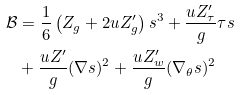Convert formula to latex. <formula><loc_0><loc_0><loc_500><loc_500>\mathcal { B } & = \frac { 1 } { 6 } \left ( Z _ { g } + 2 u Z _ { g } ^ { \prime } \right ) s ^ { 3 } + \frac { u Z _ { \tau } ^ { \prime } } { g } \tau s \\ & + \frac { u Z ^ { \prime } } { g } ( \nabla s ) ^ { 2 } + \frac { u Z _ { w } ^ { \prime } } { g } ( \nabla _ { \theta } s ) ^ { 2 }</formula> 